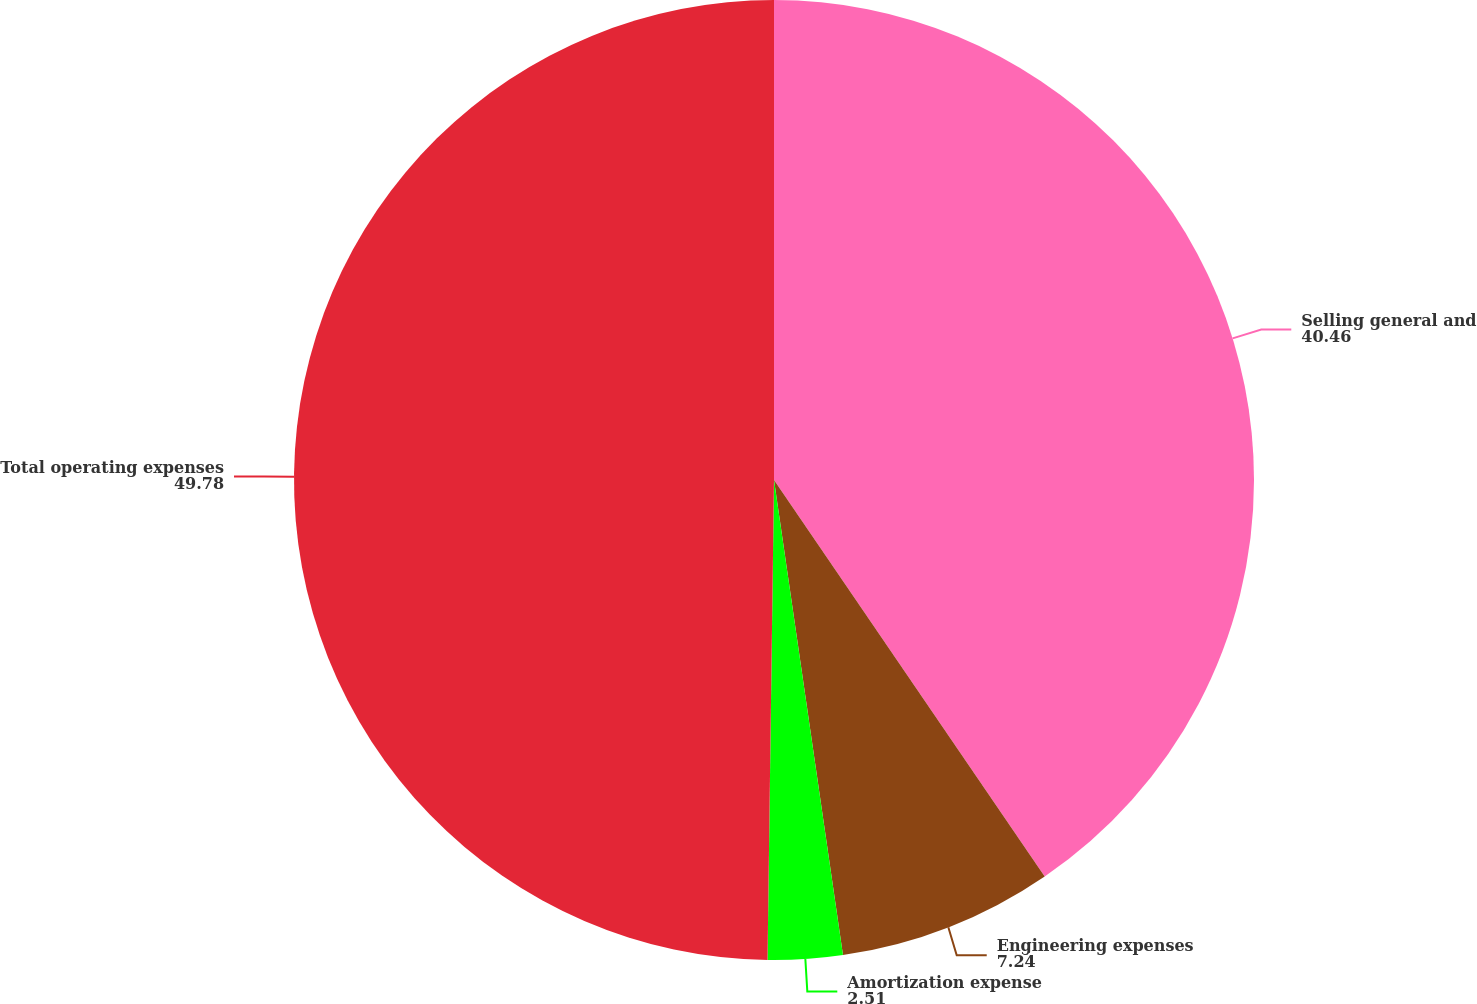Convert chart. <chart><loc_0><loc_0><loc_500><loc_500><pie_chart><fcel>Selling general and<fcel>Engineering expenses<fcel>Amortization expense<fcel>Total operating expenses<nl><fcel>40.46%<fcel>7.24%<fcel>2.51%<fcel>49.78%<nl></chart> 